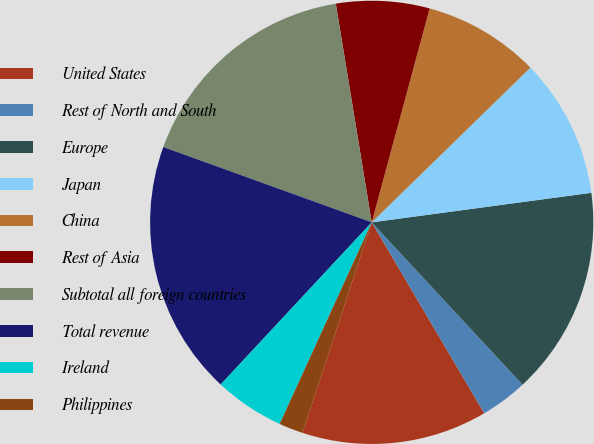<chart> <loc_0><loc_0><loc_500><loc_500><pie_chart><fcel>United States<fcel>Rest of North and South<fcel>Europe<fcel>Japan<fcel>China<fcel>Rest of Asia<fcel>Subtotal all foreign countries<fcel>Total revenue<fcel>Ireland<fcel>Philippines<nl><fcel>13.53%<fcel>3.44%<fcel>15.21%<fcel>10.17%<fcel>8.49%<fcel>6.8%<fcel>16.89%<fcel>18.58%<fcel>5.12%<fcel>1.76%<nl></chart> 